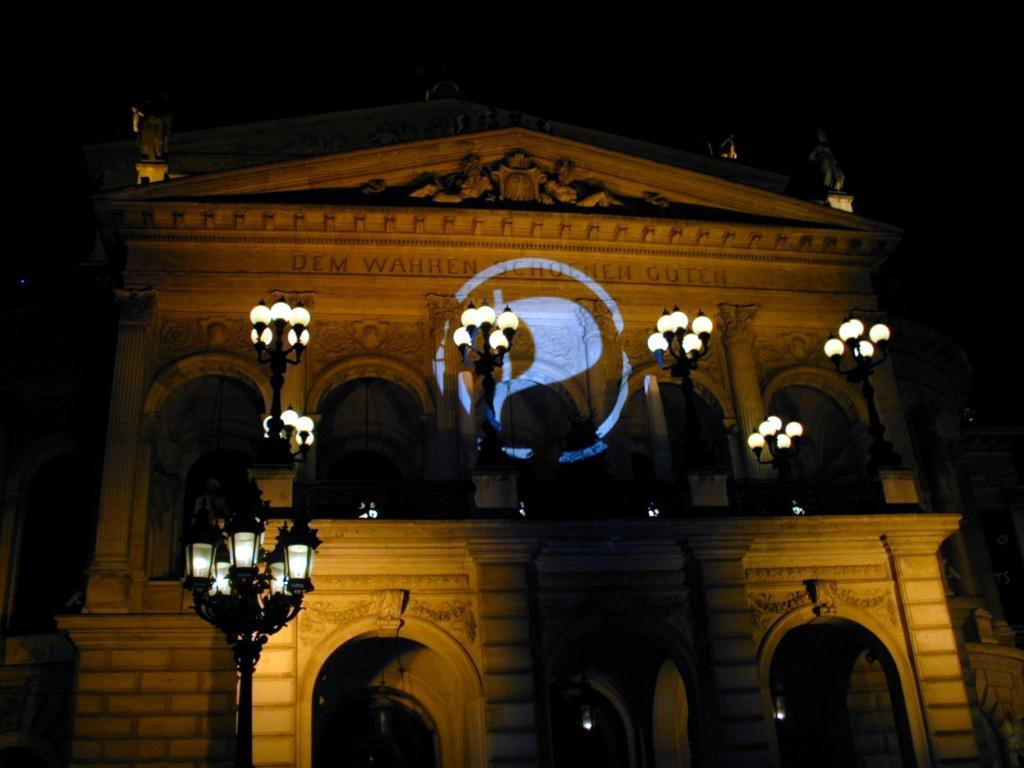What type of structure is present in the image? There is a building in the image. What can be seen illuminated in the image? There are lights visible in the image. What is visible in the background of the image? The sky is visible in the background of the image. What type of noise can be heard coming from the building in the image? There is no indication of any noise in the image, as it only features a building, lights, and the sky. 